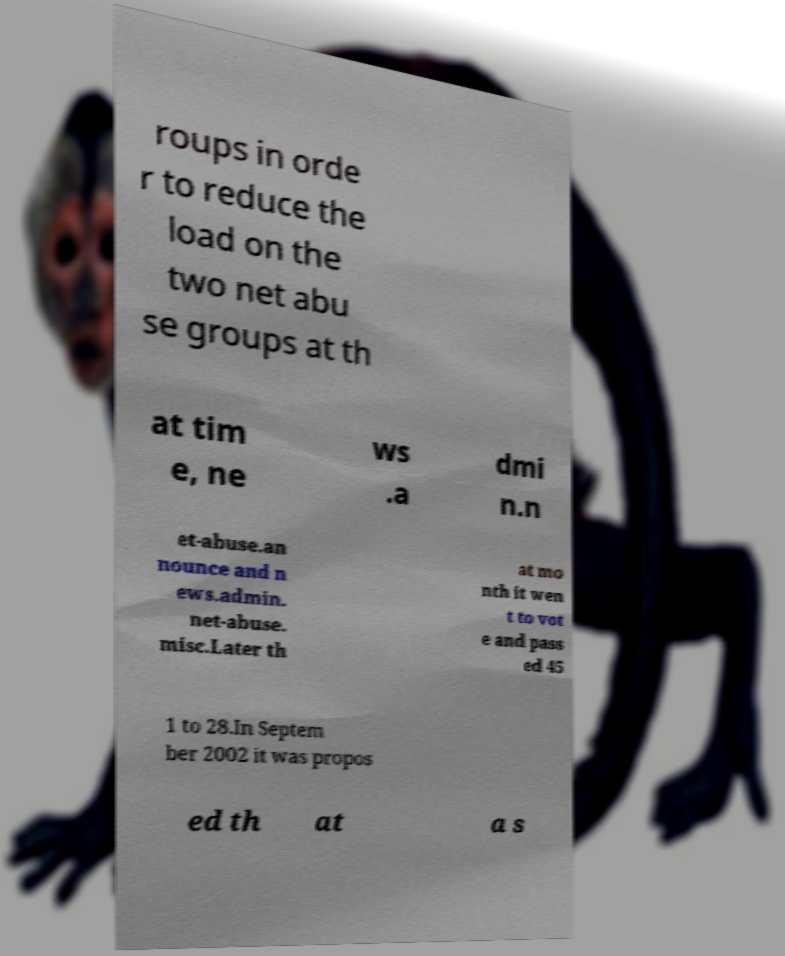Please read and relay the text visible in this image. What does it say? roups in orde r to reduce the load on the two net abu se groups at th at tim e, ne ws .a dmi n.n et-abuse.an nounce and n ews.admin. net-abuse. misc.Later th at mo nth it wen t to vot e and pass ed 45 1 to 28.In Septem ber 2002 it was propos ed th at a s 